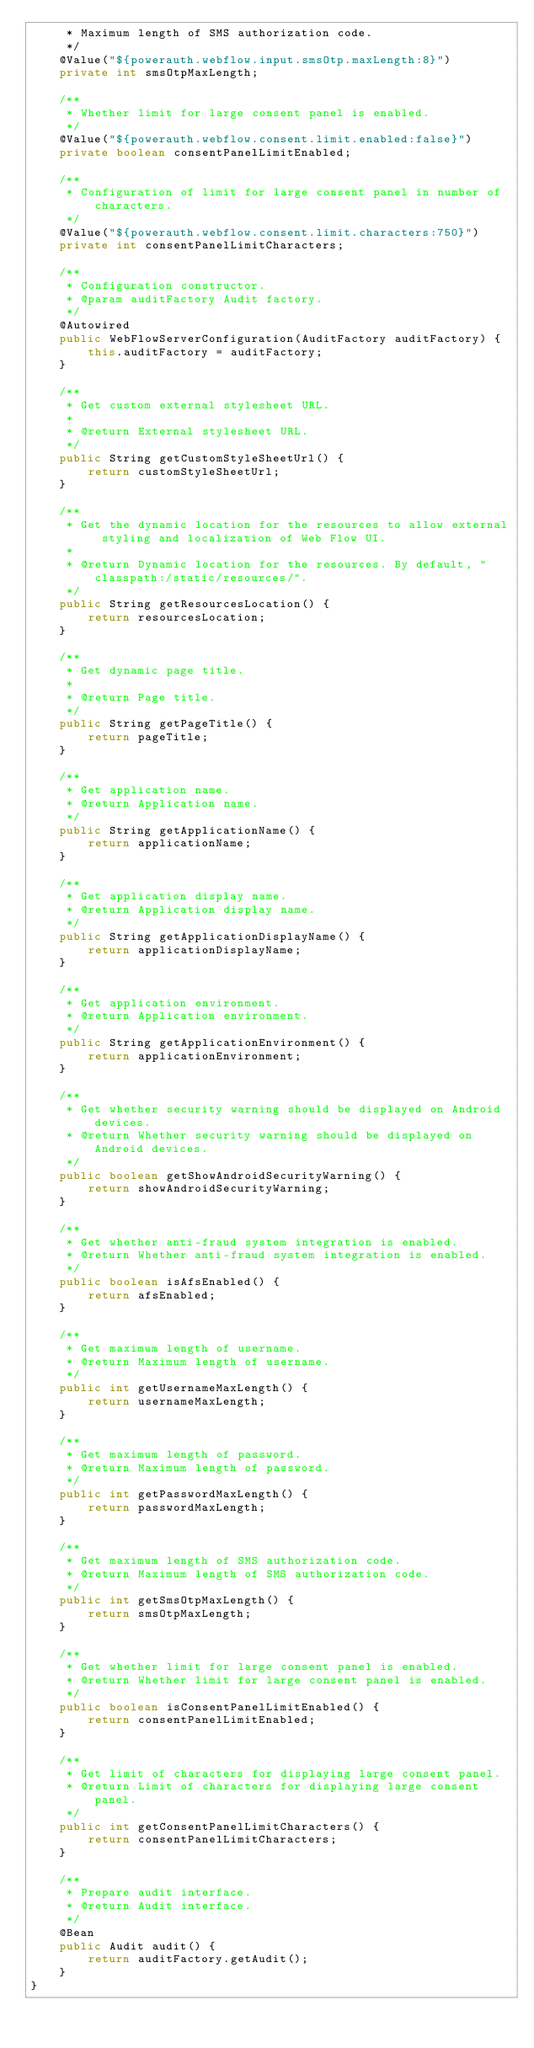<code> <loc_0><loc_0><loc_500><loc_500><_Java_>     * Maximum length of SMS authorization code.
     */
    @Value("${powerauth.webflow.input.smsOtp.maxLength:8}")
    private int smsOtpMaxLength;

    /**
     * Whether limit for large consent panel is enabled.
     */
    @Value("${powerauth.webflow.consent.limit.enabled:false}")
    private boolean consentPanelLimitEnabled;

    /**
     * Configuration of limit for large consent panel in number of characters.
     */
    @Value("${powerauth.webflow.consent.limit.characters:750}")
    private int consentPanelLimitCharacters;

    /**
     * Configuration constructor.
     * @param auditFactory Audit factory.
     */
    @Autowired
    public WebFlowServerConfiguration(AuditFactory auditFactory) {
        this.auditFactory = auditFactory;
    }

    /**
     * Get custom external stylesheet URL.
     *
     * @return External stylesheet URL.
     */
    public String getCustomStyleSheetUrl() {
        return customStyleSheetUrl;
    }

    /**
     * Get the dynamic location for the resources to allow external styling and localization of Web Flow UI.
     *
     * @return Dynamic location for the resources. By default, "classpath:/static/resources/".
     */
    public String getResourcesLocation() {
        return resourcesLocation;
    }

    /**
     * Get dynamic page title.
     *
     * @return Page title.
     */
    public String getPageTitle() {
        return pageTitle;
    }

    /**
     * Get application name.
     * @return Application name.
     */
    public String getApplicationName() {
        return applicationName;
    }

    /**
     * Get application display name.
     * @return Application display name.
     */
    public String getApplicationDisplayName() {
        return applicationDisplayName;
    }

    /**
     * Get application environment.
     * @return Application environment.
     */
    public String getApplicationEnvironment() {
        return applicationEnvironment;
    }

    /**
     * Get whether security warning should be displayed on Android devices.
     * @return Whether security warning should be displayed on Android devices.
     */
    public boolean getShowAndroidSecurityWarning() {
        return showAndroidSecurityWarning;
    }

    /**
     * Get whether anti-fraud system integration is enabled.
     * @return Whether anti-fraud system integration is enabled.
     */
    public boolean isAfsEnabled() {
        return afsEnabled;
    }

    /**
     * Get maximum length of username.
     * @return Maximum length of username.
     */
    public int getUsernameMaxLength() {
        return usernameMaxLength;
    }

    /**
     * Get maximum length of password.
     * @return Maximum length of password.
     */
    public int getPasswordMaxLength() {
        return passwordMaxLength;
    }

    /**
     * Get maximum length of SMS authorization code.
     * @return Maximum length of SMS authorization code.
     */
    public int getSmsOtpMaxLength() {
        return smsOtpMaxLength;
    }

    /**
     * Get whether limit for large consent panel is enabled.
     * @return Whether limit for large consent panel is enabled.
     */
    public boolean isConsentPanelLimitEnabled() {
        return consentPanelLimitEnabled;
    }

    /**
     * Get limit of characters for displaying large consent panel.
     * @return Limit of characters for displaying large consent panel.
     */
    public int getConsentPanelLimitCharacters() {
        return consentPanelLimitCharacters;
    }

    /**
     * Prepare audit interface.
     * @return Audit interface.
     */
    @Bean
    public Audit audit() {
        return auditFactory.getAudit();
    }
}
</code> 